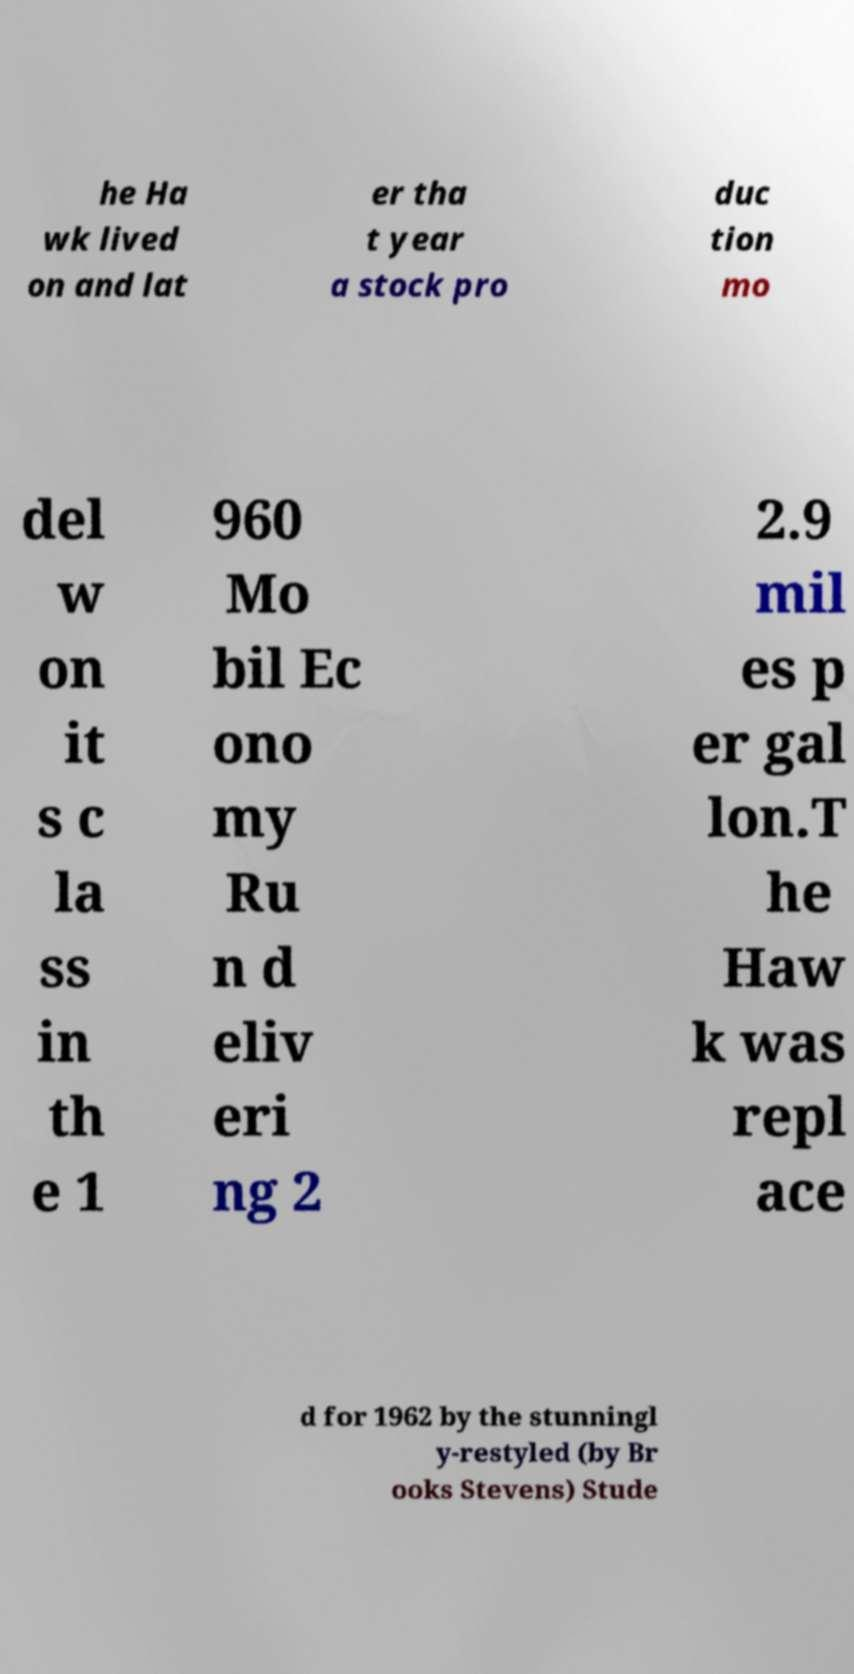Please read and relay the text visible in this image. What does it say? he Ha wk lived on and lat er tha t year a stock pro duc tion mo del w on it s c la ss in th e 1 960 Mo bil Ec ono my Ru n d eliv eri ng 2 2.9 mil es p er gal lon.T he Haw k was repl ace d for 1962 by the stunningl y-restyled (by Br ooks Stevens) Stude 